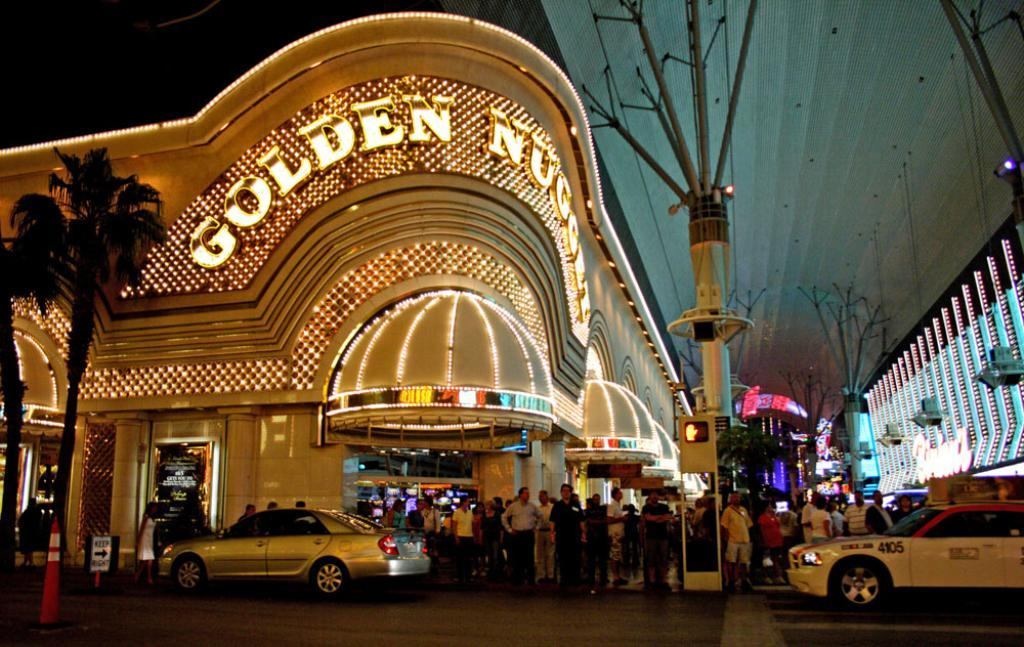<image>
Present a compact description of the photo's key features. a place with golden nugget written on it 